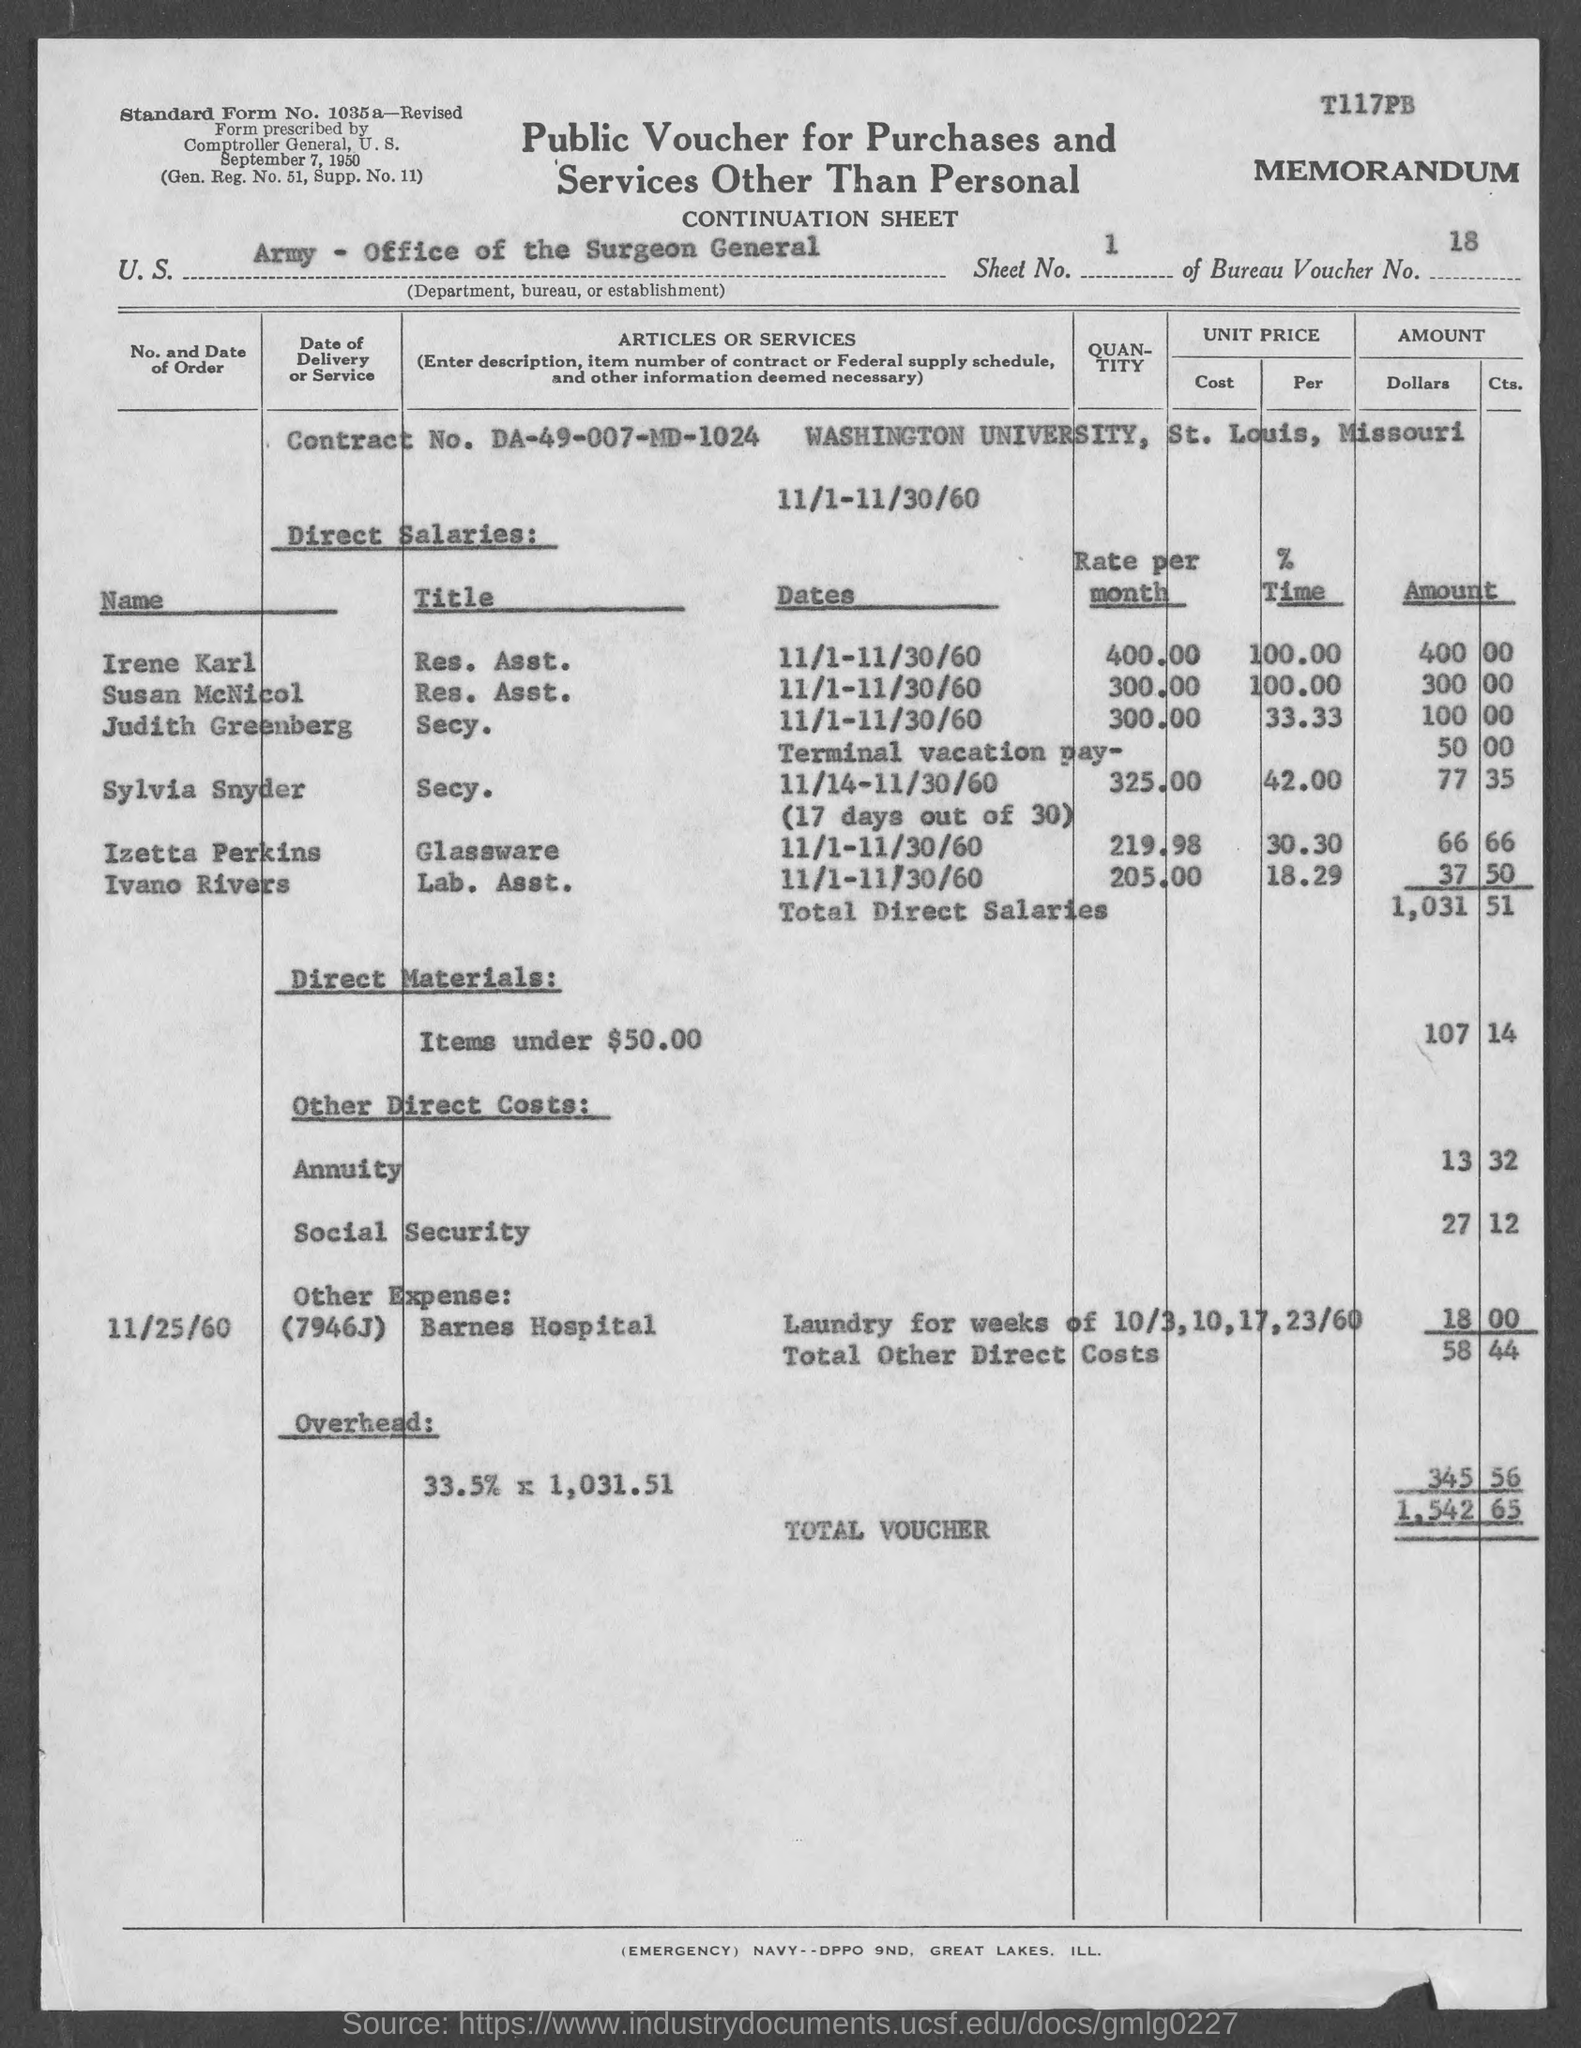What is the bureau voucher no.?
Keep it short and to the point. 18. What is the sheet no.?
Your response must be concise. 1. What is the standard form no.?
Keep it short and to the point. 1035a. What is gen. reg. no.?
Provide a succinct answer. 51. What is the supp. no. ?
Your answer should be compact. 11. What is the contract no.?
Ensure brevity in your answer.  DA-49-007-MD-1024. In which state is washington university at?
Your answer should be very brief. MISSOURI. What is the total voucher amount ?
Make the answer very short. 1,542.65. What is the title of irene karl?
Provide a succinct answer. Res. Asst. What is the title of susan mcnicol ?
Offer a terse response. Res. asst. 